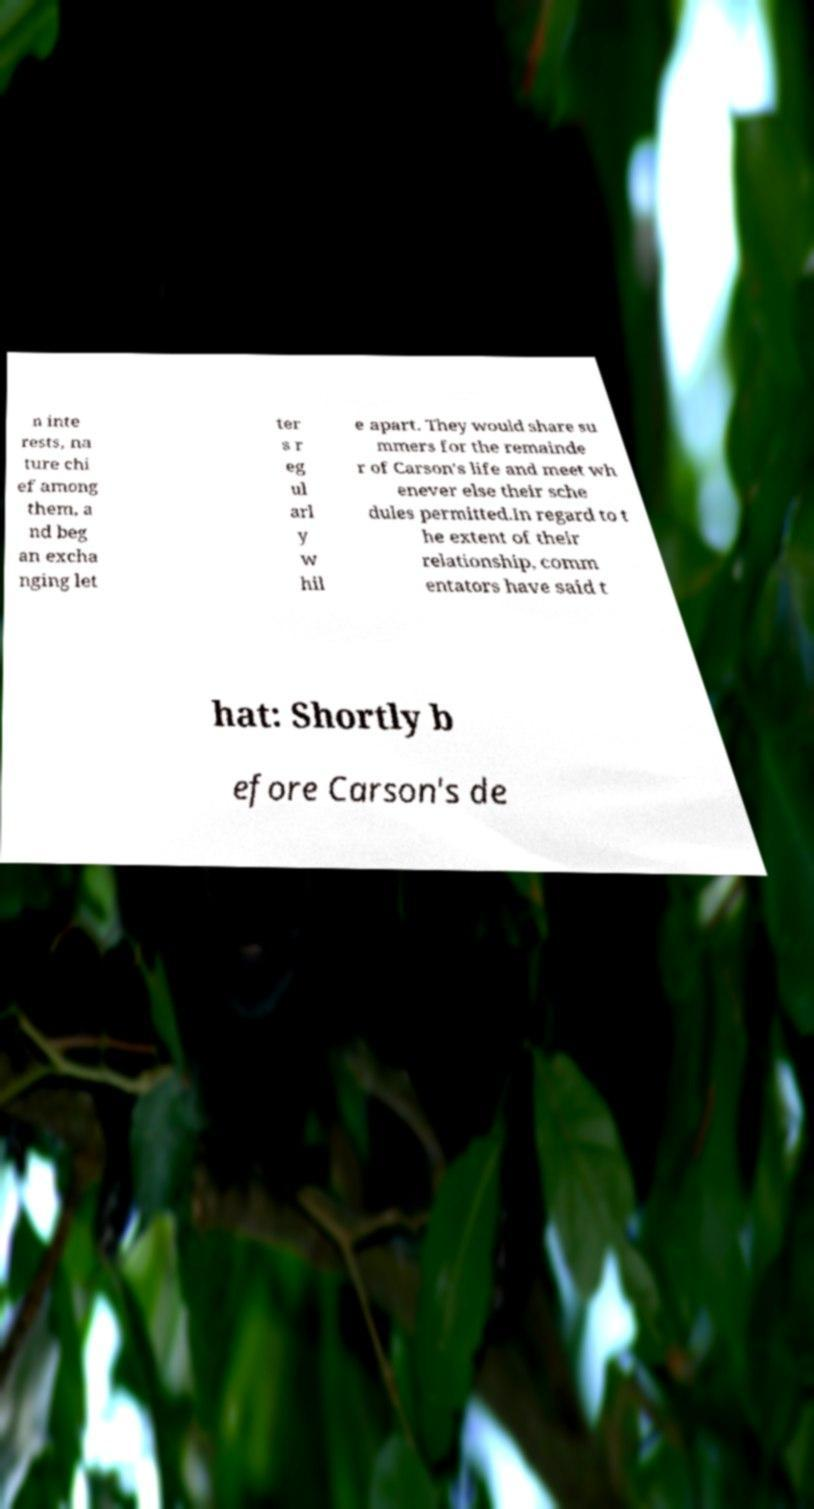Can you accurately transcribe the text from the provided image for me? n inte rests, na ture chi ef among them, a nd beg an excha nging let ter s r eg ul arl y w hil e apart. They would share su mmers for the remainde r of Carson's life and meet wh enever else their sche dules permitted.In regard to t he extent of their relationship, comm entators have said t hat: Shortly b efore Carson's de 